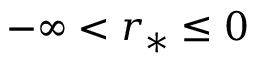Convert formula to latex. <formula><loc_0><loc_0><loc_500><loc_500>- \infty < r _ { * } \leq 0</formula> 